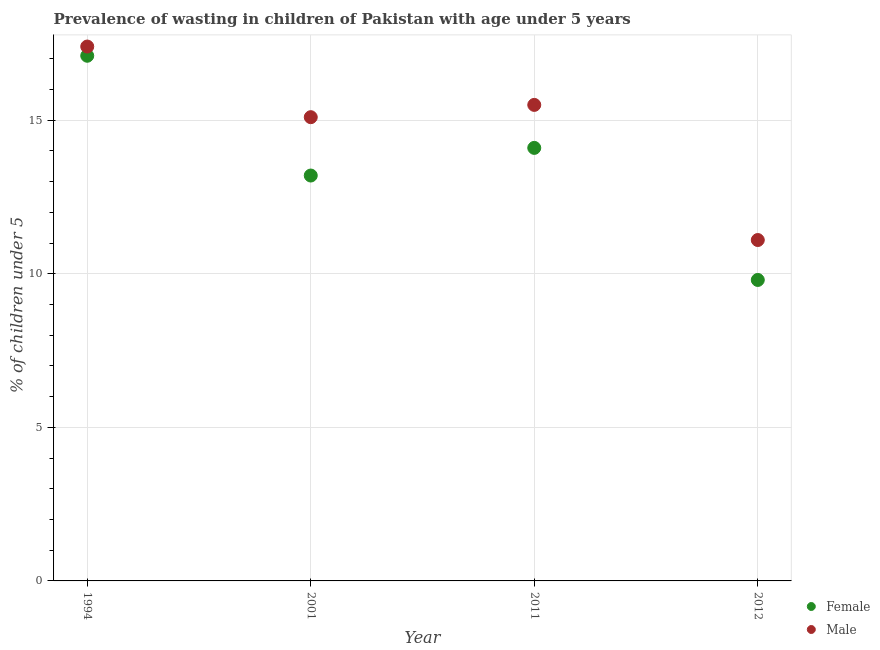How many different coloured dotlines are there?
Offer a terse response. 2. What is the percentage of undernourished male children in 1994?
Give a very brief answer. 17.4. Across all years, what is the maximum percentage of undernourished female children?
Keep it short and to the point. 17.1. Across all years, what is the minimum percentage of undernourished male children?
Offer a very short reply. 11.1. In which year was the percentage of undernourished female children maximum?
Your answer should be compact. 1994. What is the total percentage of undernourished female children in the graph?
Your answer should be compact. 54.2. What is the difference between the percentage of undernourished female children in 1994 and the percentage of undernourished male children in 2012?
Provide a succinct answer. 6. What is the average percentage of undernourished female children per year?
Provide a succinct answer. 13.55. In the year 2001, what is the difference between the percentage of undernourished female children and percentage of undernourished male children?
Keep it short and to the point. -1.9. In how many years, is the percentage of undernourished female children greater than 13 %?
Give a very brief answer. 3. What is the ratio of the percentage of undernourished female children in 1994 to that in 2011?
Your answer should be compact. 1.21. Is the percentage of undernourished male children in 2001 less than that in 2011?
Provide a short and direct response. Yes. Is the difference between the percentage of undernourished female children in 2011 and 2012 greater than the difference between the percentage of undernourished male children in 2011 and 2012?
Provide a succinct answer. No. What is the difference between the highest and the second highest percentage of undernourished male children?
Your response must be concise. 1.9. What is the difference between the highest and the lowest percentage of undernourished male children?
Your response must be concise. 6.3. Does the percentage of undernourished female children monotonically increase over the years?
Give a very brief answer. No. Is the percentage of undernourished female children strictly greater than the percentage of undernourished male children over the years?
Keep it short and to the point. No. How many dotlines are there?
Provide a succinct answer. 2. What is the difference between two consecutive major ticks on the Y-axis?
Provide a succinct answer. 5. Are the values on the major ticks of Y-axis written in scientific E-notation?
Offer a terse response. No. Does the graph contain grids?
Offer a very short reply. Yes. Where does the legend appear in the graph?
Keep it short and to the point. Bottom right. What is the title of the graph?
Give a very brief answer. Prevalence of wasting in children of Pakistan with age under 5 years. What is the label or title of the X-axis?
Provide a short and direct response. Year. What is the label or title of the Y-axis?
Ensure brevity in your answer.   % of children under 5. What is the  % of children under 5 of Female in 1994?
Provide a short and direct response. 17.1. What is the  % of children under 5 of Male in 1994?
Provide a succinct answer. 17.4. What is the  % of children under 5 of Female in 2001?
Offer a very short reply. 13.2. What is the  % of children under 5 of Male in 2001?
Provide a short and direct response. 15.1. What is the  % of children under 5 of Female in 2011?
Your answer should be compact. 14.1. What is the  % of children under 5 of Male in 2011?
Your answer should be very brief. 15.5. What is the  % of children under 5 of Female in 2012?
Your response must be concise. 9.8. What is the  % of children under 5 of Male in 2012?
Offer a very short reply. 11.1. Across all years, what is the maximum  % of children under 5 of Female?
Your response must be concise. 17.1. Across all years, what is the maximum  % of children under 5 in Male?
Provide a succinct answer. 17.4. Across all years, what is the minimum  % of children under 5 in Female?
Your answer should be compact. 9.8. Across all years, what is the minimum  % of children under 5 in Male?
Offer a very short reply. 11.1. What is the total  % of children under 5 of Female in the graph?
Provide a succinct answer. 54.2. What is the total  % of children under 5 of Male in the graph?
Provide a succinct answer. 59.1. What is the difference between the  % of children under 5 in Male in 1994 and that in 2011?
Give a very brief answer. 1.9. What is the difference between the  % of children under 5 of Male in 1994 and that in 2012?
Your answer should be compact. 6.3. What is the difference between the  % of children under 5 of Female in 2001 and that in 2011?
Your answer should be compact. -0.9. What is the difference between the  % of children under 5 in Female in 2011 and that in 2012?
Offer a terse response. 4.3. What is the difference between the  % of children under 5 in Female in 1994 and the  % of children under 5 in Male in 2001?
Offer a very short reply. 2. What is the difference between the  % of children under 5 in Female in 1994 and the  % of children under 5 in Male in 2012?
Give a very brief answer. 6. What is the difference between the  % of children under 5 of Female in 2001 and the  % of children under 5 of Male in 2012?
Keep it short and to the point. 2.1. What is the difference between the  % of children under 5 in Female in 2011 and the  % of children under 5 in Male in 2012?
Give a very brief answer. 3. What is the average  % of children under 5 of Female per year?
Offer a very short reply. 13.55. What is the average  % of children under 5 in Male per year?
Make the answer very short. 14.78. In the year 2001, what is the difference between the  % of children under 5 in Female and  % of children under 5 in Male?
Make the answer very short. -1.9. In the year 2011, what is the difference between the  % of children under 5 in Female and  % of children under 5 in Male?
Provide a succinct answer. -1.4. What is the ratio of the  % of children under 5 of Female in 1994 to that in 2001?
Keep it short and to the point. 1.3. What is the ratio of the  % of children under 5 in Male in 1994 to that in 2001?
Offer a terse response. 1.15. What is the ratio of the  % of children under 5 of Female in 1994 to that in 2011?
Provide a short and direct response. 1.21. What is the ratio of the  % of children under 5 in Male in 1994 to that in 2011?
Offer a very short reply. 1.12. What is the ratio of the  % of children under 5 in Female in 1994 to that in 2012?
Provide a short and direct response. 1.74. What is the ratio of the  % of children under 5 in Male in 1994 to that in 2012?
Offer a very short reply. 1.57. What is the ratio of the  % of children under 5 in Female in 2001 to that in 2011?
Your response must be concise. 0.94. What is the ratio of the  % of children under 5 of Male in 2001 to that in 2011?
Your response must be concise. 0.97. What is the ratio of the  % of children under 5 of Female in 2001 to that in 2012?
Provide a succinct answer. 1.35. What is the ratio of the  % of children under 5 of Male in 2001 to that in 2012?
Your answer should be very brief. 1.36. What is the ratio of the  % of children under 5 in Female in 2011 to that in 2012?
Keep it short and to the point. 1.44. What is the ratio of the  % of children under 5 in Male in 2011 to that in 2012?
Provide a short and direct response. 1.4. What is the difference between the highest and the second highest  % of children under 5 of Female?
Your response must be concise. 3. What is the difference between the highest and the second highest  % of children under 5 of Male?
Your response must be concise. 1.9. 